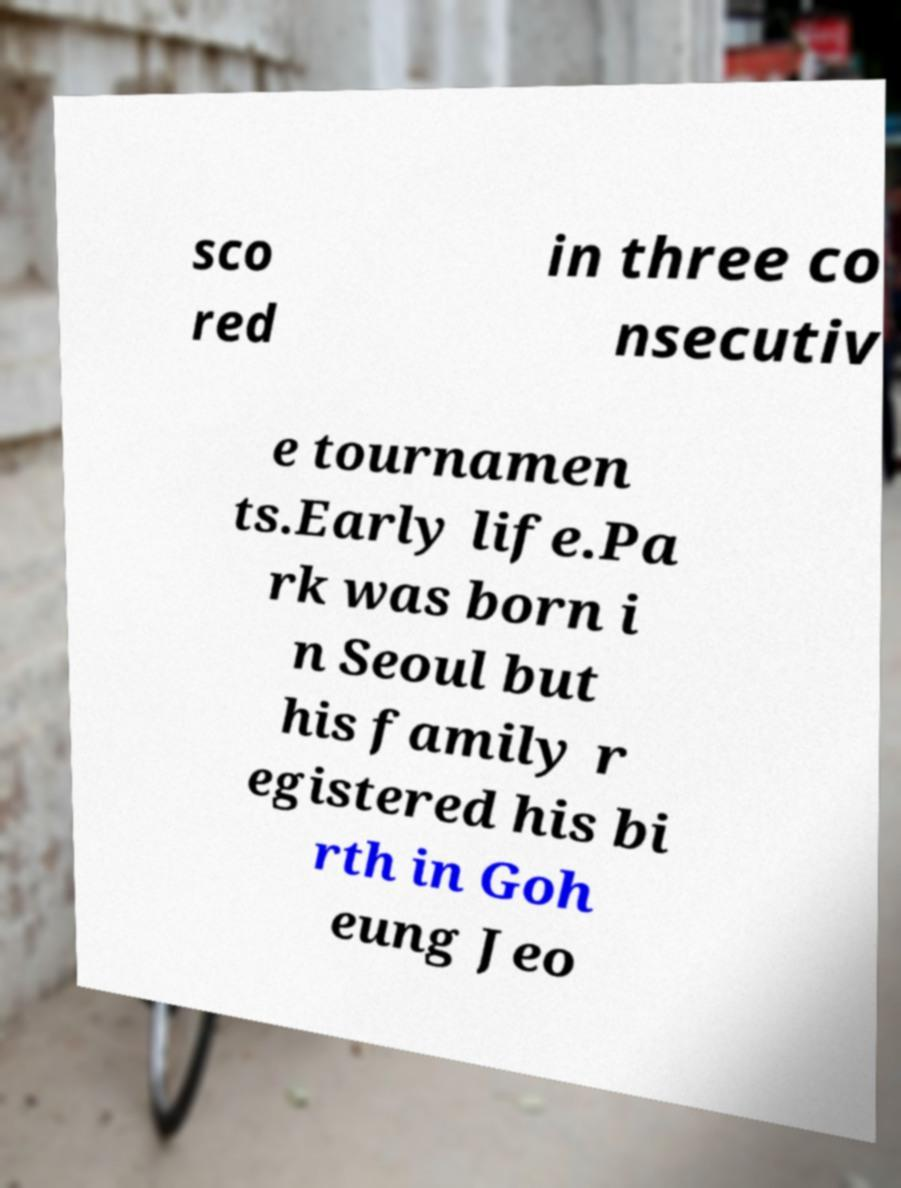Please identify and transcribe the text found in this image. sco red in three co nsecutiv e tournamen ts.Early life.Pa rk was born i n Seoul but his family r egistered his bi rth in Goh eung Jeo 